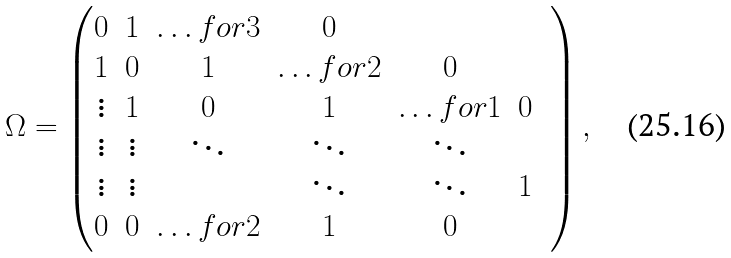<formula> <loc_0><loc_0><loc_500><loc_500>\Omega = \begin{pmatrix} 0 & 1 & \hdots f o r { 3 } & 0 \\ 1 & 0 & 1 & \hdots f o r { 2 } & 0 \\ \vdots & 1 & 0 & 1 & \hdots f o r { 1 } & 0 \\ \vdots & \vdots & \ddots & \ddots & \ddots & & \\ \vdots & \vdots & & \ddots & \ddots & 1 \\ 0 & 0 & \hdots f o r { 2 } & 1 & 0 \\ \end{pmatrix} ,</formula> 